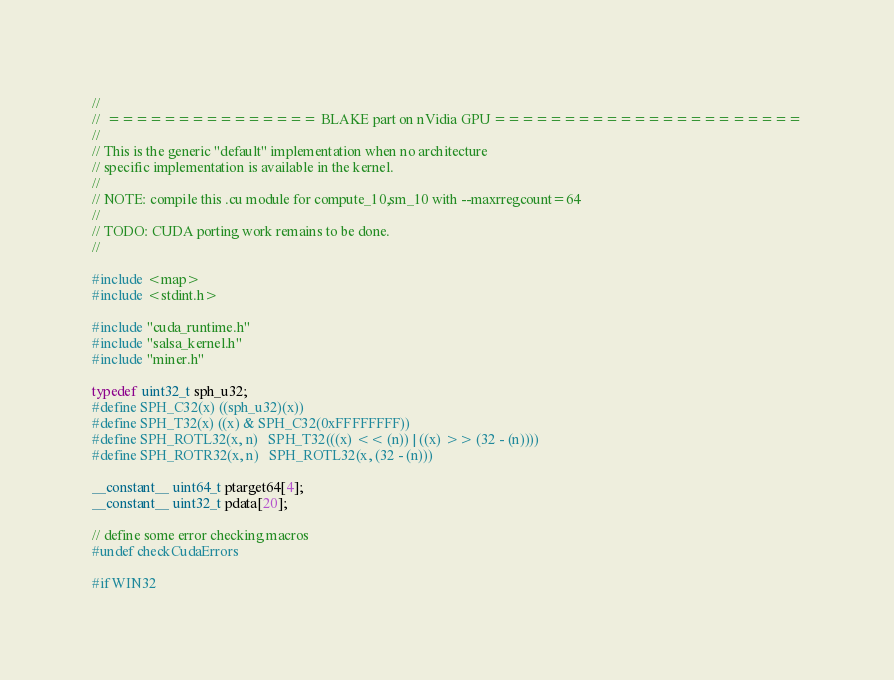<code> <loc_0><loc_0><loc_500><loc_500><_Cuda_>//
//  =============== BLAKE part on nVidia GPU ======================
//
// This is the generic "default" implementation when no architecture
// specific implementation is available in the kernel.
//
// NOTE: compile this .cu module for compute_10,sm_10 with --maxrregcount=64
//
// TODO: CUDA porting work remains to be done.
//

#include <map>
#include <stdint.h>

#include "cuda_runtime.h"
#include "salsa_kernel.h"
#include "miner.h"

typedef uint32_t sph_u32;
#define SPH_C32(x) ((sph_u32)(x))
#define SPH_T32(x) ((x) & SPH_C32(0xFFFFFFFF))
#define SPH_ROTL32(x, n)   SPH_T32(((x) << (n)) | ((x) >> (32 - (n))))
#define SPH_ROTR32(x, n)   SPH_ROTL32(x, (32 - (n)))

__constant__ uint64_t ptarget64[4];
__constant__ uint32_t pdata[20];

// define some error checking macros
#undef checkCudaErrors

#if WIN32</code> 